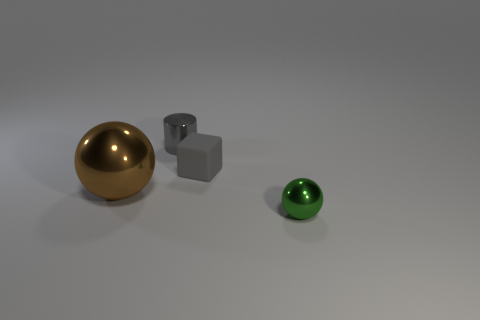Is there any other thing that is made of the same material as the tiny gray block?
Provide a short and direct response. No. How many other objects are there of the same size as the metal cylinder?
Your response must be concise. 2. The small block has what color?
Your response must be concise. Gray. What number of metal things are either tiny gray cylinders or small yellow blocks?
Your answer should be very brief. 1. What is the size of the object that is in front of the metal sphere behind the sphere to the right of the large metal ball?
Provide a succinct answer. Small. How big is the object that is behind the small green metallic object and in front of the tiny rubber thing?
Keep it short and to the point. Large. Is the color of the metal thing that is behind the gray rubber cube the same as the matte cube to the right of the tiny gray cylinder?
Your answer should be compact. Yes. How many small balls are to the left of the tiny matte thing?
Ensure brevity in your answer.  0. There is a ball that is behind the tiny thing that is in front of the tiny cube; is there a gray rubber block that is behind it?
Ensure brevity in your answer.  Yes. What number of green shiny objects are the same size as the brown object?
Your answer should be very brief. 0. 